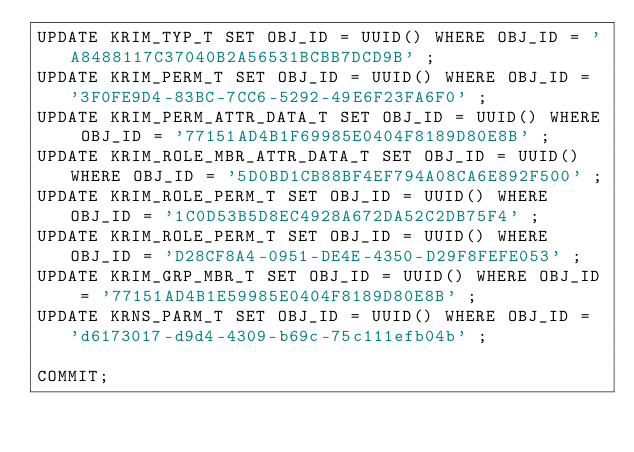<code> <loc_0><loc_0><loc_500><loc_500><_SQL_>UPDATE KRIM_TYP_T SET OBJ_ID = UUID() WHERE OBJ_ID = 'A8488117C37040B2A56531BCBB7DCD9B' ;
UPDATE KRIM_PERM_T SET OBJ_ID = UUID() WHERE OBJ_ID = '3F0FE9D4-83BC-7CC6-5292-49E6F23FA6F0' ;
UPDATE KRIM_PERM_ATTR_DATA_T SET OBJ_ID = UUID() WHERE OBJ_ID = '77151AD4B1F69985E0404F8189D80E8B' ;
UPDATE KRIM_ROLE_MBR_ATTR_DATA_T SET OBJ_ID = UUID() WHERE OBJ_ID = '5D0BD1CB88BF4EF794A08CA6E892F500' ;
UPDATE KRIM_ROLE_PERM_T SET OBJ_ID = UUID() WHERE OBJ_ID = '1C0D53B5D8EC4928A672DA52C2DB75F4' ;
UPDATE KRIM_ROLE_PERM_T SET OBJ_ID = UUID() WHERE OBJ_ID = 'D28CF8A4-0951-DE4E-4350-D29F8FEFE053' ;
UPDATE KRIM_GRP_MBR_T SET OBJ_ID = UUID() WHERE OBJ_ID = '77151AD4B1E59985E0404F8189D80E8B' ;
UPDATE KRNS_PARM_T SET OBJ_ID = UUID() WHERE OBJ_ID = 'd6173017-d9d4-4309-b69c-75c111efb04b' ;

COMMIT;</code> 